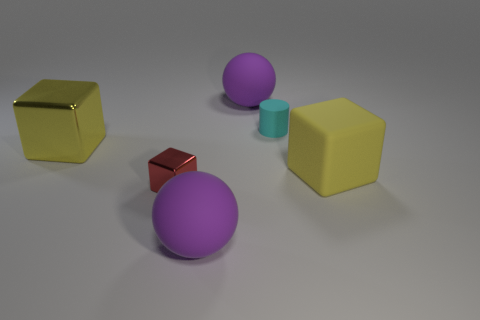Add 2 big purple balls. How many objects exist? 8 Subtract all spheres. How many objects are left? 4 Subtract all small cylinders. Subtract all small green matte objects. How many objects are left? 5 Add 1 yellow rubber things. How many yellow rubber things are left? 2 Add 2 large brown rubber cylinders. How many large brown rubber cylinders exist? 2 Subtract 0 green cylinders. How many objects are left? 6 